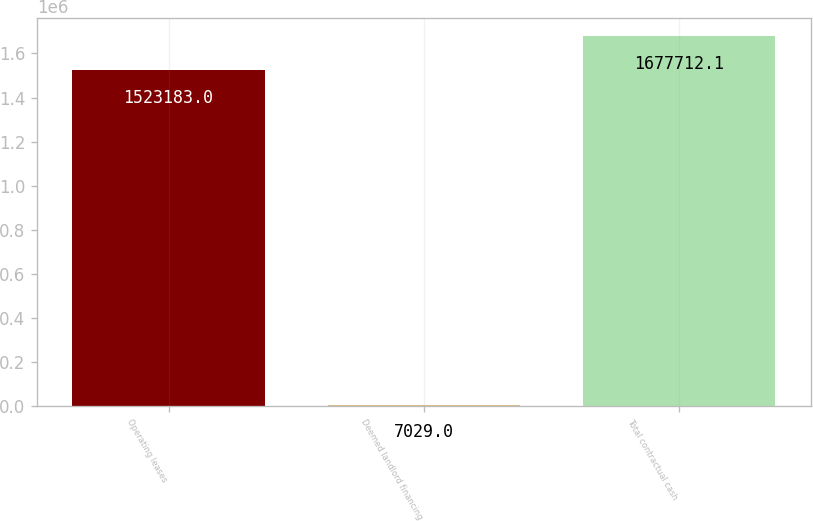Convert chart. <chart><loc_0><loc_0><loc_500><loc_500><bar_chart><fcel>Operating leases<fcel>Deemed landlord financing<fcel>Total contractual cash<nl><fcel>1.52318e+06<fcel>7029<fcel>1.67771e+06<nl></chart> 